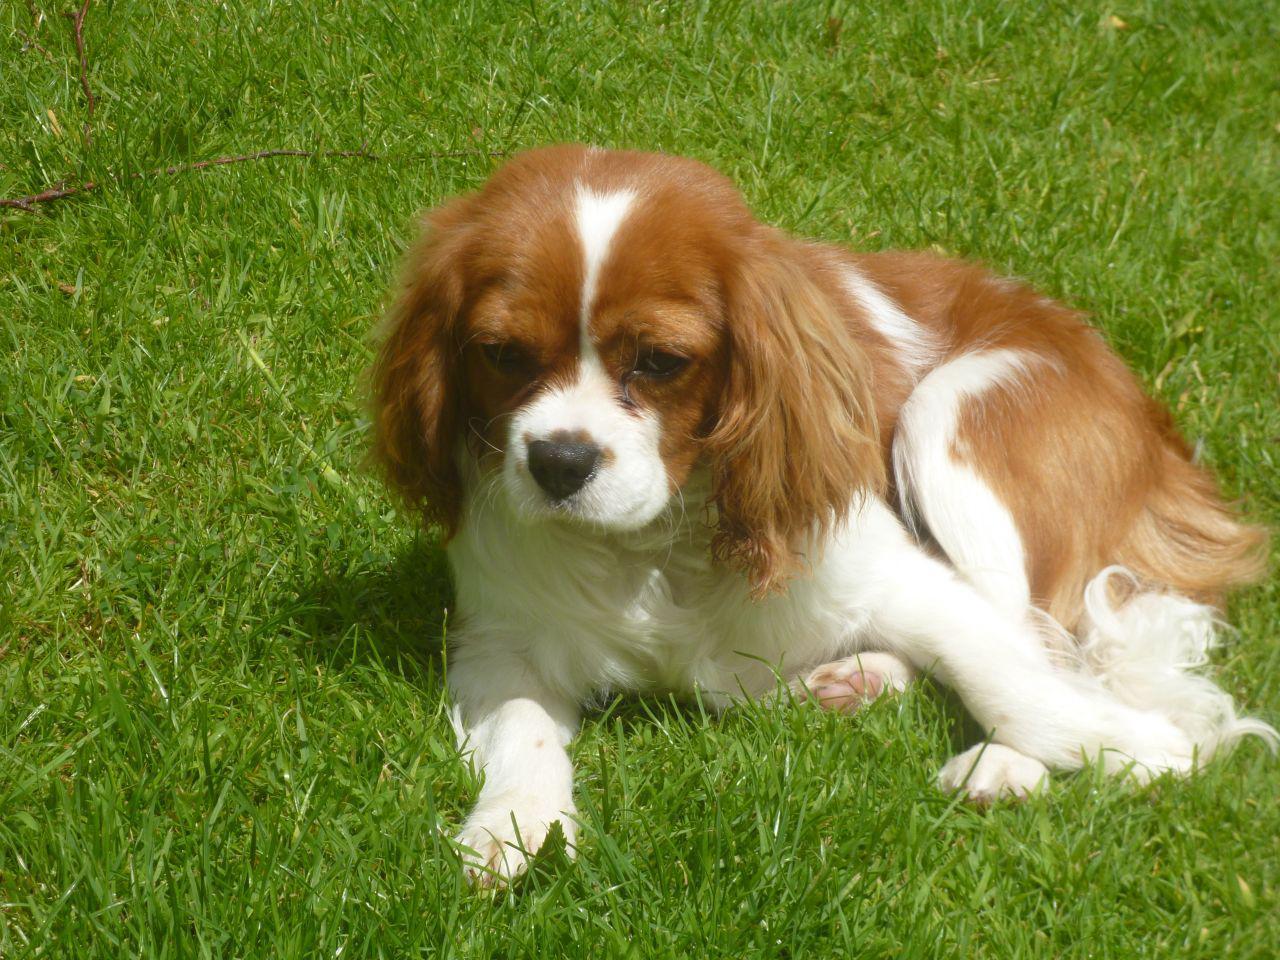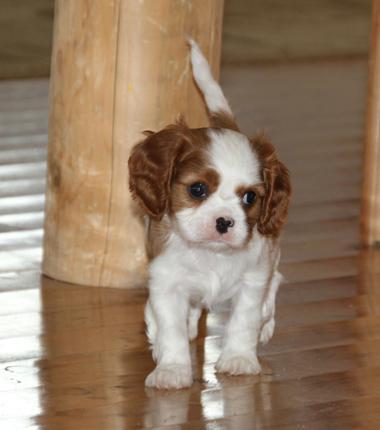The first image is the image on the left, the second image is the image on the right. Analyze the images presented: Is the assertion "An image shows a puppy reclining on the grass with head lifted." valid? Answer yes or no. Yes. The first image is the image on the left, the second image is the image on the right. Given the left and right images, does the statement "The dog on the left is sitting on the grass." hold true? Answer yes or no. Yes. 